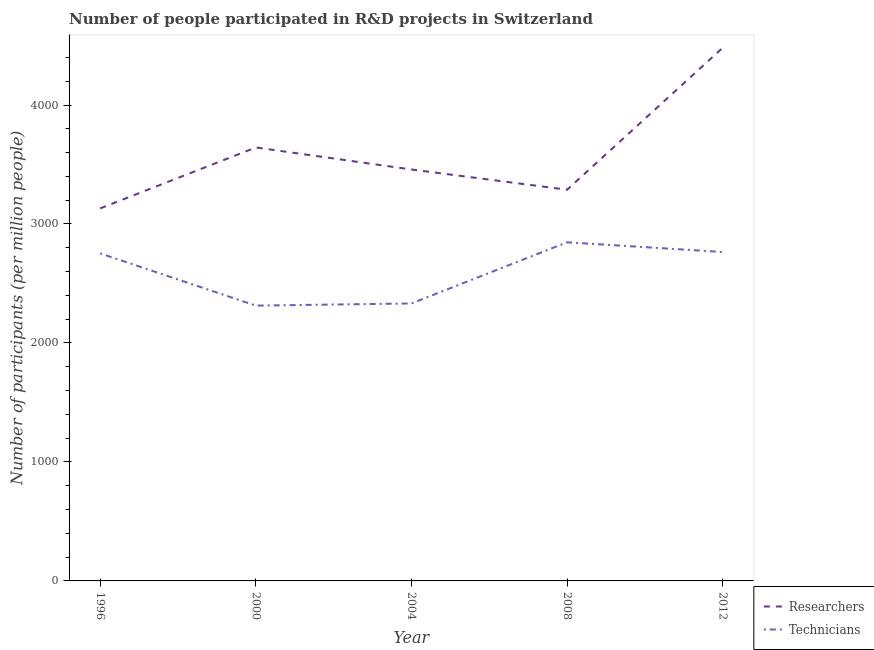How many different coloured lines are there?
Make the answer very short. 2. Is the number of lines equal to the number of legend labels?
Offer a terse response. Yes. What is the number of researchers in 2000?
Provide a succinct answer. 3643.11. Across all years, what is the maximum number of researchers?
Your answer should be compact. 4481.07. Across all years, what is the minimum number of technicians?
Keep it short and to the point. 2313.84. What is the total number of technicians in the graph?
Your answer should be very brief. 1.30e+04. What is the difference between the number of technicians in 2004 and that in 2008?
Make the answer very short. -513.96. What is the difference between the number of researchers in 2004 and the number of technicians in 1996?
Offer a terse response. 705.02. What is the average number of technicians per year?
Your answer should be compact. 2601.9. In the year 1996, what is the difference between the number of technicians and number of researchers?
Your response must be concise. -378.21. What is the ratio of the number of technicians in 1996 to that in 2012?
Your answer should be very brief. 1. Is the difference between the number of technicians in 1996 and 2012 greater than the difference between the number of researchers in 1996 and 2012?
Give a very brief answer. Yes. What is the difference between the highest and the second highest number of researchers?
Provide a succinct answer. 837.96. What is the difference between the highest and the lowest number of researchers?
Keep it short and to the point. 1349.89. In how many years, is the number of technicians greater than the average number of technicians taken over all years?
Make the answer very short. 3. Does the number of technicians monotonically increase over the years?
Ensure brevity in your answer.  No. Is the number of researchers strictly greater than the number of technicians over the years?
Provide a short and direct response. Yes. What is the difference between two consecutive major ticks on the Y-axis?
Your response must be concise. 1000. Does the graph contain any zero values?
Offer a very short reply. No. How many legend labels are there?
Your response must be concise. 2. How are the legend labels stacked?
Provide a succinct answer. Vertical. What is the title of the graph?
Offer a very short reply. Number of people participated in R&D projects in Switzerland. Does "Primary" appear as one of the legend labels in the graph?
Ensure brevity in your answer.  No. What is the label or title of the Y-axis?
Ensure brevity in your answer.  Number of participants (per million people). What is the Number of participants (per million people) of Researchers in 1996?
Your response must be concise. 3131.18. What is the Number of participants (per million people) in Technicians in 1996?
Provide a succinct answer. 2752.98. What is the Number of participants (per million people) of Researchers in 2000?
Ensure brevity in your answer.  3643.11. What is the Number of participants (per million people) of Technicians in 2000?
Keep it short and to the point. 2313.84. What is the Number of participants (per million people) of Researchers in 2004?
Ensure brevity in your answer.  3457.99. What is the Number of participants (per million people) in Technicians in 2004?
Offer a very short reply. 2332.1. What is the Number of participants (per million people) in Researchers in 2008?
Ensure brevity in your answer.  3287.98. What is the Number of participants (per million people) of Technicians in 2008?
Offer a terse response. 2846.06. What is the Number of participants (per million people) in Researchers in 2012?
Offer a terse response. 4481.07. What is the Number of participants (per million people) of Technicians in 2012?
Your answer should be very brief. 2764.52. Across all years, what is the maximum Number of participants (per million people) of Researchers?
Make the answer very short. 4481.07. Across all years, what is the maximum Number of participants (per million people) of Technicians?
Keep it short and to the point. 2846.06. Across all years, what is the minimum Number of participants (per million people) in Researchers?
Provide a succinct answer. 3131.18. Across all years, what is the minimum Number of participants (per million people) in Technicians?
Keep it short and to the point. 2313.84. What is the total Number of participants (per million people) in Researchers in the graph?
Give a very brief answer. 1.80e+04. What is the total Number of participants (per million people) of Technicians in the graph?
Offer a terse response. 1.30e+04. What is the difference between the Number of participants (per million people) in Researchers in 1996 and that in 2000?
Make the answer very short. -511.93. What is the difference between the Number of participants (per million people) of Technicians in 1996 and that in 2000?
Your answer should be very brief. 439.14. What is the difference between the Number of participants (per million people) of Researchers in 1996 and that in 2004?
Ensure brevity in your answer.  -326.81. What is the difference between the Number of participants (per million people) of Technicians in 1996 and that in 2004?
Ensure brevity in your answer.  420.87. What is the difference between the Number of participants (per million people) in Researchers in 1996 and that in 2008?
Offer a very short reply. -156.8. What is the difference between the Number of participants (per million people) of Technicians in 1996 and that in 2008?
Offer a terse response. -93.09. What is the difference between the Number of participants (per million people) in Researchers in 1996 and that in 2012?
Provide a short and direct response. -1349.89. What is the difference between the Number of participants (per million people) of Technicians in 1996 and that in 2012?
Make the answer very short. -11.55. What is the difference between the Number of participants (per million people) of Researchers in 2000 and that in 2004?
Make the answer very short. 185.12. What is the difference between the Number of participants (per million people) of Technicians in 2000 and that in 2004?
Offer a terse response. -18.27. What is the difference between the Number of participants (per million people) in Researchers in 2000 and that in 2008?
Your answer should be compact. 355.13. What is the difference between the Number of participants (per million people) of Technicians in 2000 and that in 2008?
Offer a very short reply. -532.22. What is the difference between the Number of participants (per million people) in Researchers in 2000 and that in 2012?
Offer a terse response. -837.96. What is the difference between the Number of participants (per million people) in Technicians in 2000 and that in 2012?
Your answer should be very brief. -450.68. What is the difference between the Number of participants (per million people) in Researchers in 2004 and that in 2008?
Provide a short and direct response. 170.01. What is the difference between the Number of participants (per million people) of Technicians in 2004 and that in 2008?
Your answer should be very brief. -513.96. What is the difference between the Number of participants (per million people) of Researchers in 2004 and that in 2012?
Make the answer very short. -1023.08. What is the difference between the Number of participants (per million people) of Technicians in 2004 and that in 2012?
Make the answer very short. -432.42. What is the difference between the Number of participants (per million people) of Researchers in 2008 and that in 2012?
Make the answer very short. -1193.09. What is the difference between the Number of participants (per million people) in Technicians in 2008 and that in 2012?
Offer a terse response. 81.54. What is the difference between the Number of participants (per million people) in Researchers in 1996 and the Number of participants (per million people) in Technicians in 2000?
Your answer should be compact. 817.34. What is the difference between the Number of participants (per million people) of Researchers in 1996 and the Number of participants (per million people) of Technicians in 2004?
Your response must be concise. 799.08. What is the difference between the Number of participants (per million people) of Researchers in 1996 and the Number of participants (per million people) of Technicians in 2008?
Provide a short and direct response. 285.12. What is the difference between the Number of participants (per million people) in Researchers in 1996 and the Number of participants (per million people) in Technicians in 2012?
Ensure brevity in your answer.  366.66. What is the difference between the Number of participants (per million people) in Researchers in 2000 and the Number of participants (per million people) in Technicians in 2004?
Offer a very short reply. 1311.01. What is the difference between the Number of participants (per million people) in Researchers in 2000 and the Number of participants (per million people) in Technicians in 2008?
Your answer should be compact. 797.05. What is the difference between the Number of participants (per million people) in Researchers in 2000 and the Number of participants (per million people) in Technicians in 2012?
Give a very brief answer. 878.59. What is the difference between the Number of participants (per million people) in Researchers in 2004 and the Number of participants (per million people) in Technicians in 2008?
Your response must be concise. 611.93. What is the difference between the Number of participants (per million people) of Researchers in 2004 and the Number of participants (per million people) of Technicians in 2012?
Your answer should be compact. 693.47. What is the difference between the Number of participants (per million people) of Researchers in 2008 and the Number of participants (per million people) of Technicians in 2012?
Make the answer very short. 523.46. What is the average Number of participants (per million people) in Researchers per year?
Give a very brief answer. 3600.27. What is the average Number of participants (per million people) in Technicians per year?
Keep it short and to the point. 2601.9. In the year 1996, what is the difference between the Number of participants (per million people) in Researchers and Number of participants (per million people) in Technicians?
Your answer should be very brief. 378.21. In the year 2000, what is the difference between the Number of participants (per million people) in Researchers and Number of participants (per million people) in Technicians?
Your answer should be compact. 1329.27. In the year 2004, what is the difference between the Number of participants (per million people) in Researchers and Number of participants (per million people) in Technicians?
Give a very brief answer. 1125.89. In the year 2008, what is the difference between the Number of participants (per million people) in Researchers and Number of participants (per million people) in Technicians?
Offer a very short reply. 441.92. In the year 2012, what is the difference between the Number of participants (per million people) in Researchers and Number of participants (per million people) in Technicians?
Offer a very short reply. 1716.55. What is the ratio of the Number of participants (per million people) in Researchers in 1996 to that in 2000?
Make the answer very short. 0.86. What is the ratio of the Number of participants (per million people) of Technicians in 1996 to that in 2000?
Offer a terse response. 1.19. What is the ratio of the Number of participants (per million people) of Researchers in 1996 to that in 2004?
Ensure brevity in your answer.  0.91. What is the ratio of the Number of participants (per million people) in Technicians in 1996 to that in 2004?
Provide a succinct answer. 1.18. What is the ratio of the Number of participants (per million people) in Researchers in 1996 to that in 2008?
Your answer should be compact. 0.95. What is the ratio of the Number of participants (per million people) of Technicians in 1996 to that in 2008?
Your answer should be very brief. 0.97. What is the ratio of the Number of participants (per million people) in Researchers in 1996 to that in 2012?
Your response must be concise. 0.7. What is the ratio of the Number of participants (per million people) of Researchers in 2000 to that in 2004?
Keep it short and to the point. 1.05. What is the ratio of the Number of participants (per million people) of Technicians in 2000 to that in 2004?
Provide a succinct answer. 0.99. What is the ratio of the Number of participants (per million people) of Researchers in 2000 to that in 2008?
Provide a short and direct response. 1.11. What is the ratio of the Number of participants (per million people) of Technicians in 2000 to that in 2008?
Give a very brief answer. 0.81. What is the ratio of the Number of participants (per million people) of Researchers in 2000 to that in 2012?
Your answer should be very brief. 0.81. What is the ratio of the Number of participants (per million people) of Technicians in 2000 to that in 2012?
Keep it short and to the point. 0.84. What is the ratio of the Number of participants (per million people) of Researchers in 2004 to that in 2008?
Keep it short and to the point. 1.05. What is the ratio of the Number of participants (per million people) of Technicians in 2004 to that in 2008?
Ensure brevity in your answer.  0.82. What is the ratio of the Number of participants (per million people) in Researchers in 2004 to that in 2012?
Your answer should be compact. 0.77. What is the ratio of the Number of participants (per million people) in Technicians in 2004 to that in 2012?
Provide a succinct answer. 0.84. What is the ratio of the Number of participants (per million people) in Researchers in 2008 to that in 2012?
Provide a succinct answer. 0.73. What is the ratio of the Number of participants (per million people) in Technicians in 2008 to that in 2012?
Ensure brevity in your answer.  1.03. What is the difference between the highest and the second highest Number of participants (per million people) in Researchers?
Give a very brief answer. 837.96. What is the difference between the highest and the second highest Number of participants (per million people) in Technicians?
Make the answer very short. 81.54. What is the difference between the highest and the lowest Number of participants (per million people) in Researchers?
Provide a succinct answer. 1349.89. What is the difference between the highest and the lowest Number of participants (per million people) of Technicians?
Provide a short and direct response. 532.22. 